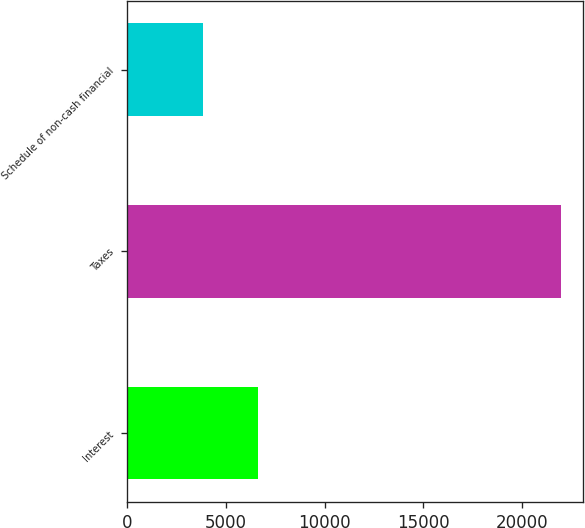<chart> <loc_0><loc_0><loc_500><loc_500><bar_chart><fcel>Interest<fcel>Taxes<fcel>Schedule of non-cash financial<nl><fcel>6633<fcel>22013<fcel>3846<nl></chart> 